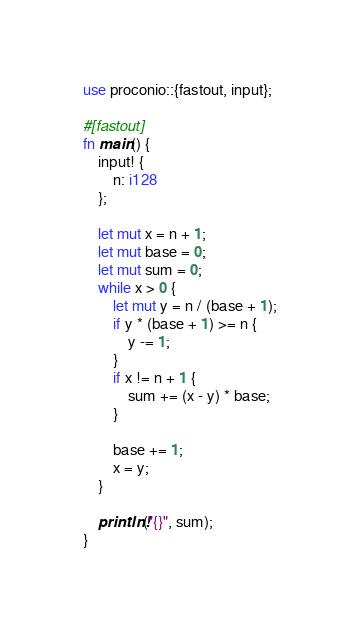<code> <loc_0><loc_0><loc_500><loc_500><_Rust_>use proconio::{fastout, input};

#[fastout]
fn main() {
    input! {
        n: i128
    };

    let mut x = n + 1;
    let mut base = 0;
    let mut sum = 0;
    while x > 0 {
        let mut y = n / (base + 1);
        if y * (base + 1) >= n {
            y -= 1;
        }
        if x != n + 1 {
            sum += (x - y) * base;
        }

        base += 1;
        x = y;
    }

    println!("{}", sum);
}
</code> 